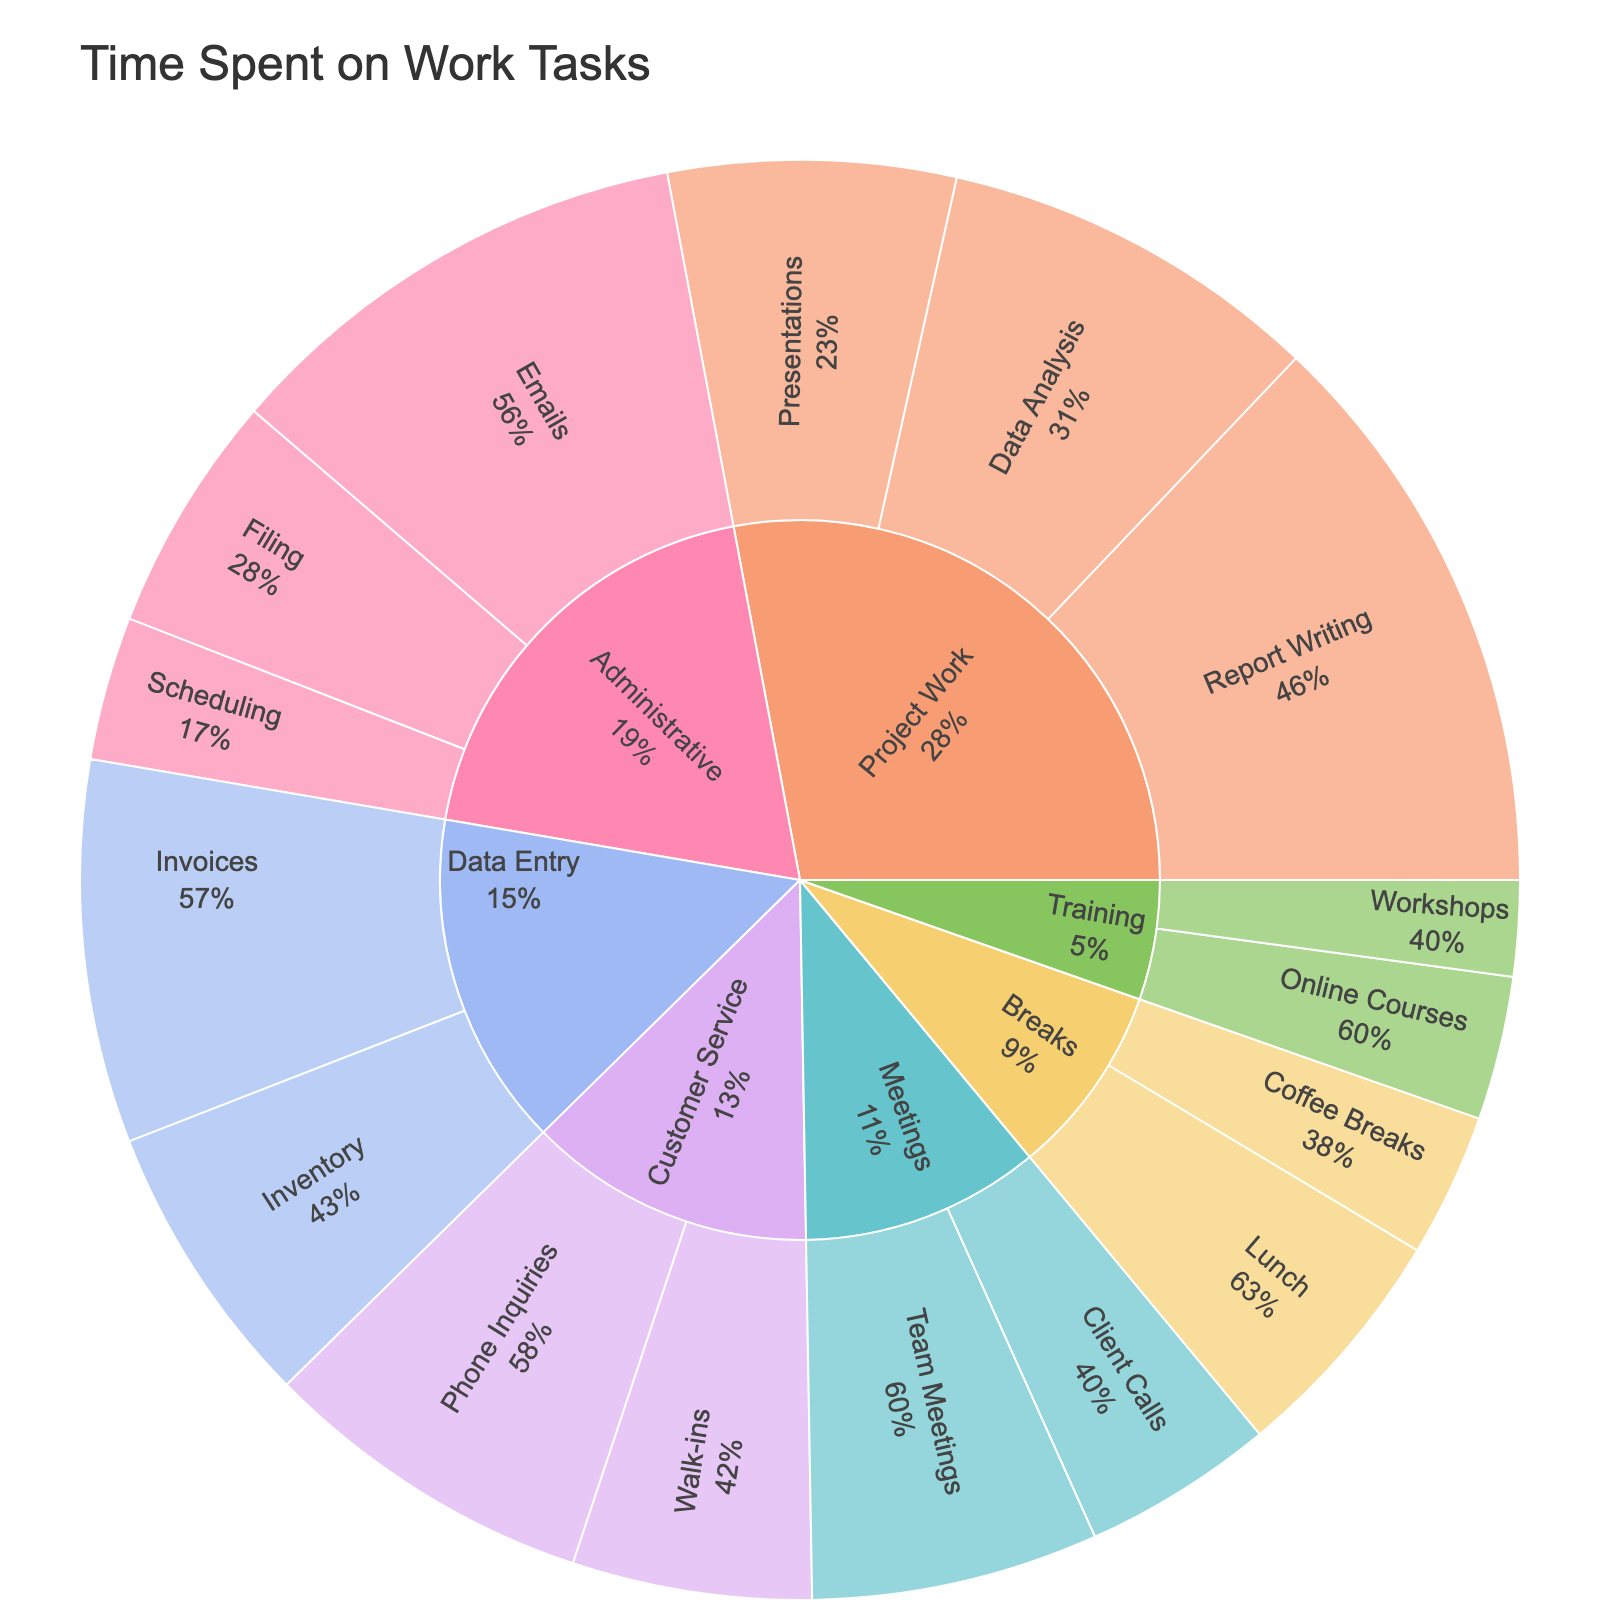What is the total time spent on Administrative tasks? To determine the total time spent on Administrative tasks, we sum up the time spent on Emails (10 hours), Filing (5 hours), and Scheduling (3 hours). So, 10 + 5 + 3 = 18 hours.
Answer: 18 hours Which subtask within Project Work has the highest time allocation? Within Project Work, we look at the subtasks: Report Writing (12 hours), Data Analysis (8 hours), and Presentations (6 hours). The subtask with the highest time allocation is Report Writing with 12 hours.
Answer: Report Writing How many hours are spent on Breaks in total? Adding the time spent on Lunch (5 hours) and Coffee Breaks (3 hours) gives us 5 + 3 = 8 hours in total.
Answer: 8 hours Compare the total time spent on Meetings and Customer Service tasks. Which one has more hours? To compare, we sum the time for Meetings (Team Meetings: 6 hours, Client Calls: 4 hours) = 6 + 4 = 10 hours. For Customer Service (Phone Inquiries: 7 hours, Walk-ins: 5 hours) = 7 + 5 = 12 hours. Customer Service has more hours with 12 hours compared to Meetings with 10 hours.
Answer: Customer Service What percentage of time is spent on Training compared to the total time spent on work tasks? First, sum the total time for all tasks: Administrative (18 hours) + Meetings (10 hours) + Data Entry (14 hours) + Customer Service (12 hours) + Project Work (26 hours) + Training (5 hours) + Breaks (8 hours) = 93 hours. Then, find the percentage for Training (5 hours), so (5/93) * 100 ≈ 5.38%.
Answer: Approximately 5.38% Which subtask in Customer Service takes the most time? We compare the time for Phone Inquiries (7 hours) and Walk-ins (5 hours). The subtask with the most time is Phone Inquiries with 7 hours.
Answer: Phone Inquiries What is the most time-consuming task overall? By comparing the totals for each task category, we find that Project Work has 26 hours, the most time-consuming task category.
Answer: Project Work How does the time spent on Data Entry compare to the time spent on Training and Breaks combined? Sum the time for Training (5 hours) and Breaks (8 hours) to get 5 + 8 = 13 hours. Data Entry sums to 14 hours. Therefore, Data Entry has more time spent (14 hours) compared to Training and Breaks combined (13 hours).
Answer: Data Entry has more time, 14 hours vs. 13 hours What is the least time-consuming subtask under Administrative work? Compare the time for Emails (10 hours), Filing (5 hours), and Scheduling (3 hours). Scheduling, with 3 hours, is the least time-consuming subtask under Administrative work.
Answer: Scheduling What is the combined time spent on subtasks under Meetings and Data Entry? For Meetings (Team Meetings: 6 hours, Client Calls: 4 hours) = 6 + 4 = 10 hours. For Data Entry (Invoices: 8 hours, Inventory: 6 hours) = 8 + 6 = 14 hours. Combined time is 10 + 14 = 24 hours.
Answer: 24 hours 